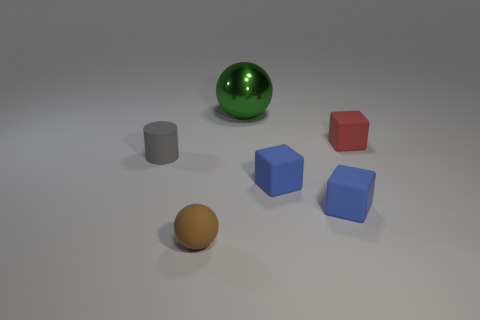Subtract all small blue rubber cubes. How many cubes are left? 1 Add 4 green things. How many objects exist? 10 Subtract all spheres. How many objects are left? 4 Subtract all purple cubes. Subtract all large metal things. How many objects are left? 5 Add 6 gray things. How many gray things are left? 7 Add 5 tiny yellow metallic spheres. How many tiny yellow metallic spheres exist? 5 Subtract 0 green cylinders. How many objects are left? 6 